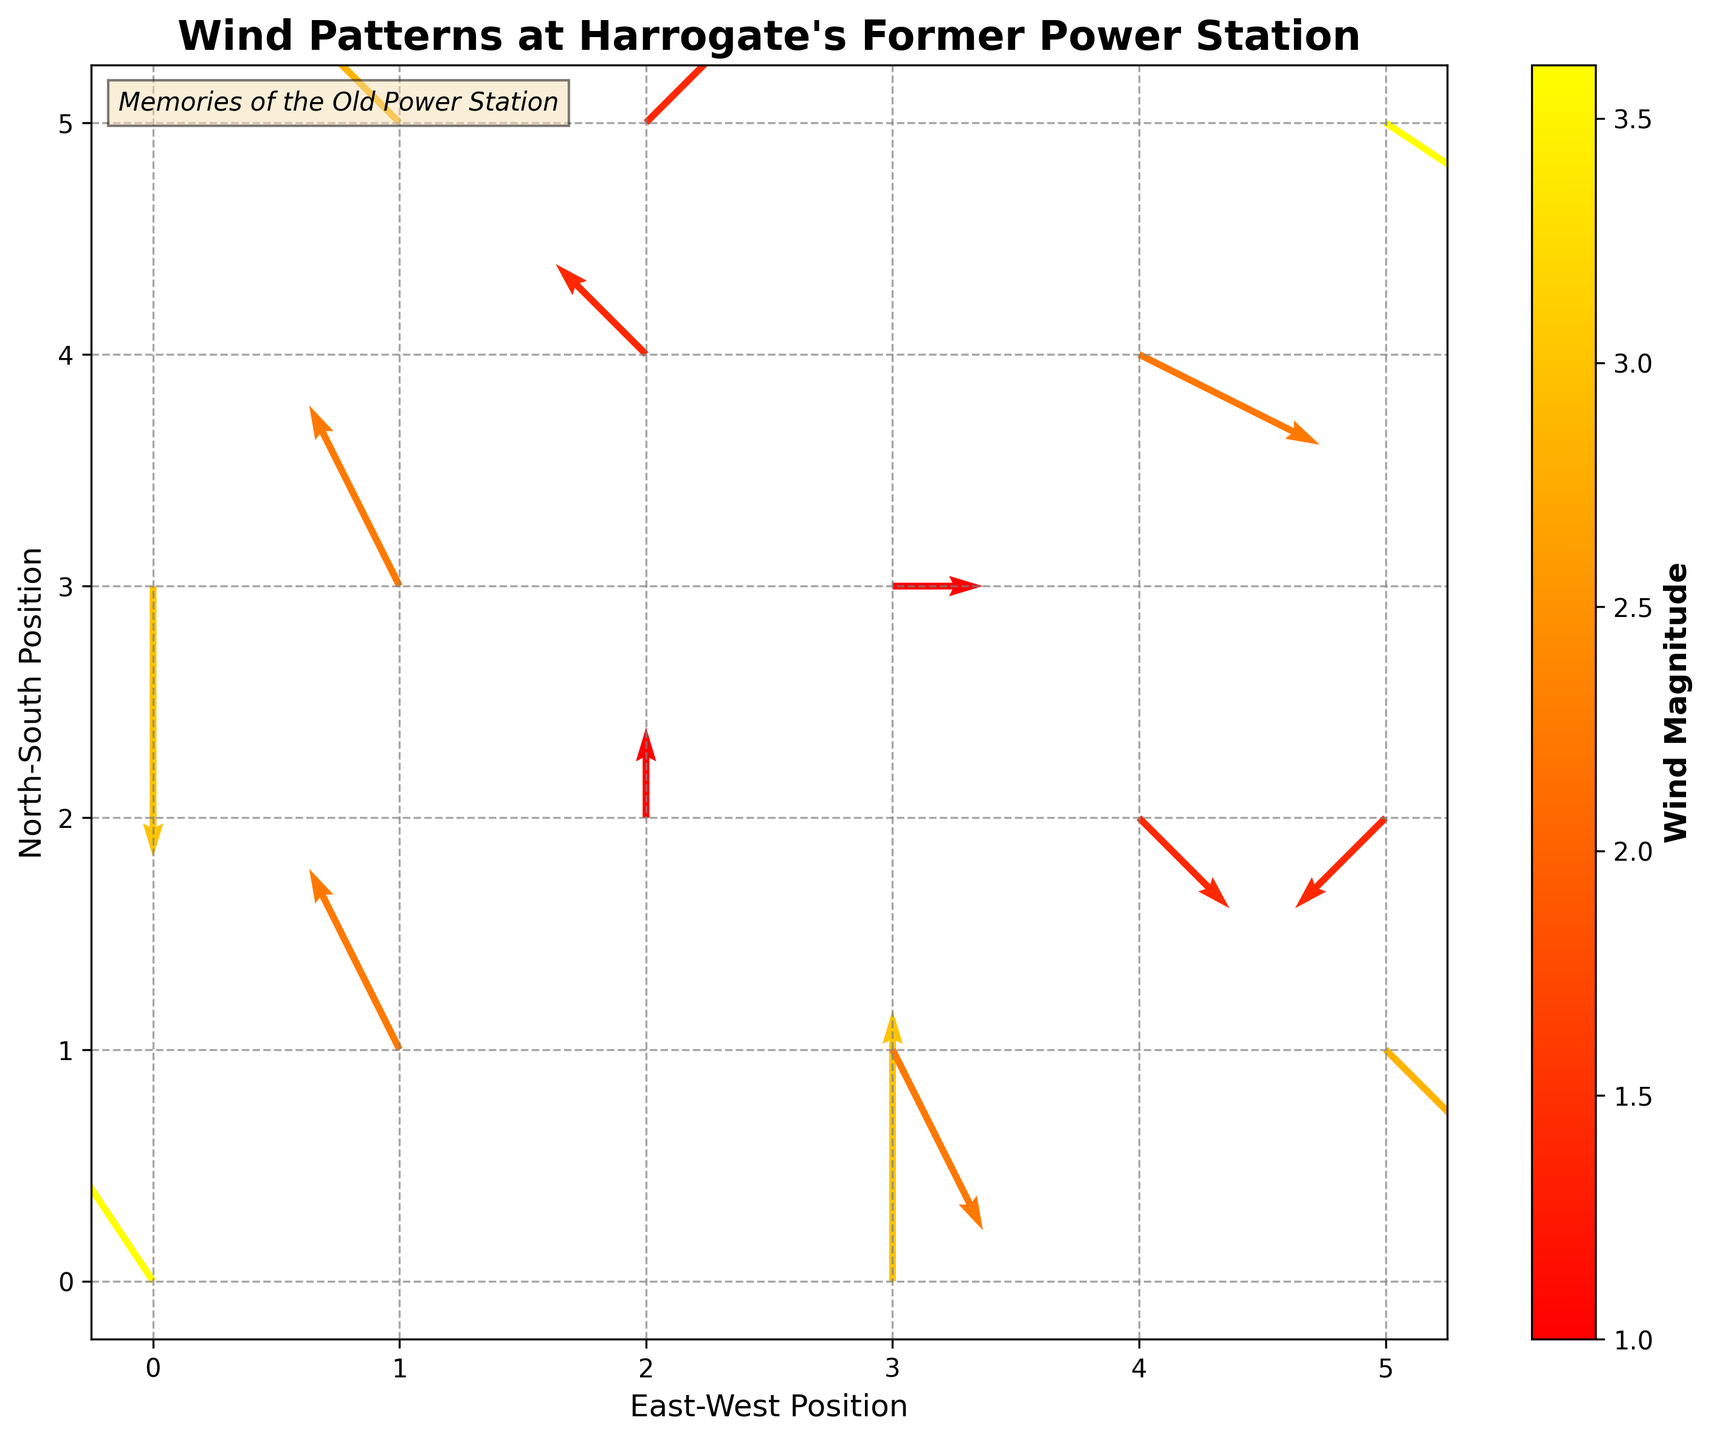What's the title of the figure? The title is located at the top of the figure, usually above the plot area. It provides an overview of what the figure is about. Here, it reads "Wind Patterns at Harrogate's Former Power Station."
Answer: Wind Patterns at Harrogate's Former Power Station How many arrows (data points) are shown in the figure? By counting each arrow present in the quiver plot, we can determine the number of data points. The dataset provides 16 arrows.
Answer: 16 Which direction do most of the arrows point in general: North, South, East, or West? Observing the quiver directions, many arrows point towards the northeast and southwest, but overall, more arrows show a component towards the west.
Answer: West What is the wind magnitude represented by the colorbar? The colorbar on the right side of the figure shows a range of values that represent wind magnitudes with varying colors. The magnitude ranges from light to dark on a specified scale. Here, it ranges from about 1 to 3.6.
Answer: 1 to 3.6 How does the arrow at position (0, 0) differ from the one at position (5, 5)? Comparing the arrows visually, at (0, 0), the arrow points northwest with a magnitude of 3.61, while at (5, 5), the arrow points southwest with the same magnitude of 3.61.
Answer: Both have the same magnitude of 3.61, directions differ Which arrow has the smallest wind magnitude, and what is its value? By observing the color of the arrows that correspond to the lightest color on the color scale, the smallest magnitudes (least dark color) are visible. The arrows at (2, 2) and (3, 3) have the smallest magnitude, which is 1.00.
Answer: Arrows at (2, 2) and (3, 3), magnitude 1.00 How many arrows indicate a magnitude greater than 2.5? By looking at the color bar and identifying the arrows with darker shades (magnitude > 2.5), we count the corresponding arrows visually in the plot. There are 5 such arrows.
Answer: 5 What's the average magnitude of the arrows at positions (1, 1), (2, 2), and (3, 3)? Add the magnitudes of these arrows: 2.24 (at (1, 1)), 1.00 (at (2, 2)), and 1.00 (at (3, 3)), then divide by 3 to find the average. (2.24 + 1.00 + 1.00) / 3 = 1.41
Answer: 1.41 Which arrow shows a significantly different pattern from the others at similar positions? By comparing arrows at similar positions (e.g., edges or center), the arrow at (5, 1) pointing southeast shows a different pattern compared to others mostly pointing generally to the west.
Answer: Arrow at (5, 1) 